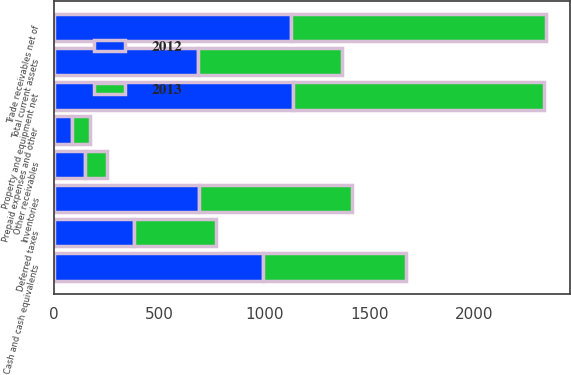Convert chart to OTSL. <chart><loc_0><loc_0><loc_500><loc_500><stacked_bar_chart><ecel><fcel>Cash and cash equivalents<fcel>Trade receivables net of<fcel>Other receivables<fcel>Inventories<fcel>Deferred taxes<fcel>Prepaid expenses and other<fcel>Total current assets<fcel>Property and equipment net<nl><fcel>2012<fcel>992.4<fcel>1126.4<fcel>147.9<fcel>688.4<fcel>377.7<fcel>84.9<fcel>684<fcel>1134.5<nl><fcel>2013<fcel>679.6<fcel>1213<fcel>100.9<fcel>728.9<fcel>393<fcel>86.6<fcel>684<fcel>1194.2<nl></chart> 